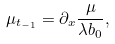<formula> <loc_0><loc_0><loc_500><loc_500>\mu _ { t _ { - 1 } } = \partial _ { x } \frac { \mu } { \lambda b _ { 0 } } ,</formula> 